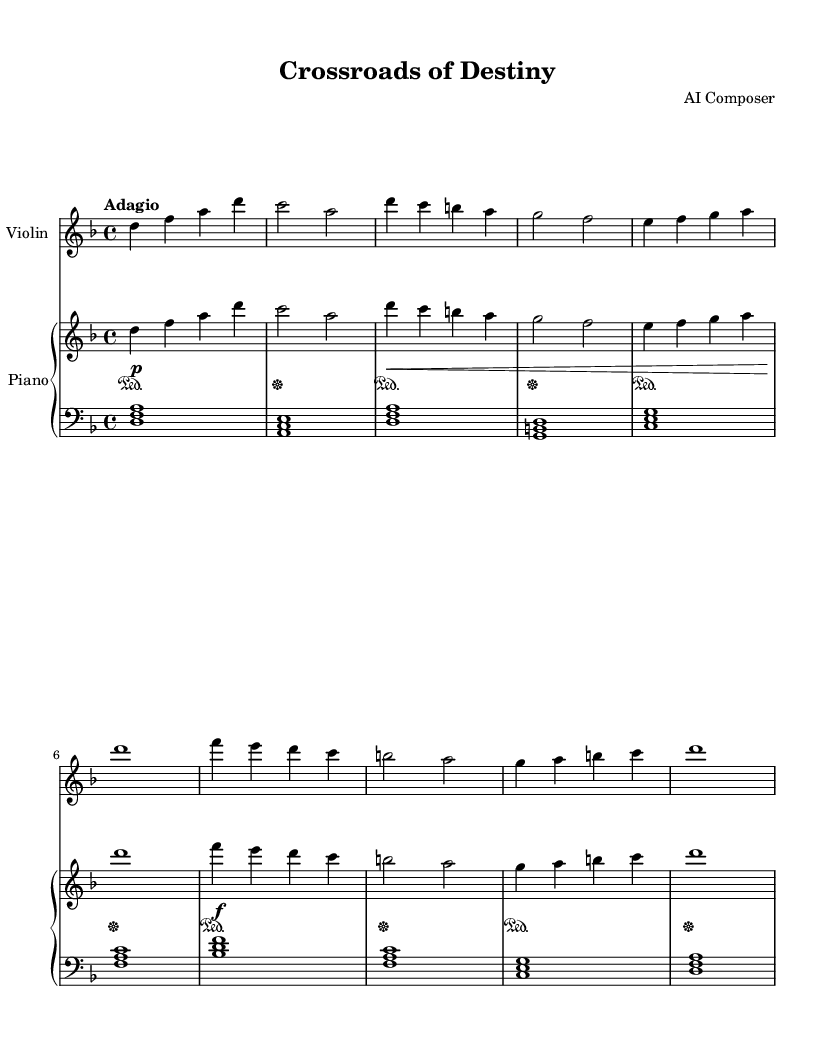What is the key signature of this music? The key signature is indicated at the beginning of the staff. In this case, there are six flats, which corresponds to the key of D minor.
Answer: D minor What is the time signature of this music? The time signature appears at the beginning of the score, shown as a fraction with a four on top and a four on the bottom. This indicates that there are four beats in each measure, and a quarter note gets one beat.
Answer: Four-four What is the tempo marking for this piece? The tempo marking is typically indicated just above the staff and is written as "Adagio." This term indicates a slow and leisurely pace.
Answer: Adagio How many sections are present in the music? By examining the structure of the score, it can be identified that there are two distinct sections, labeled as "Section A" and "Section B," which showcase varied themes or ideas.
Answer: Two What is the highest note in Section A? In Section A, the notes progress from D down to A. The highest note, looking at the given notes, is D.
Answer: D What dynamics are indicated in the music? The dynamics are detailed in the score, which shows various symbols representing how loud or soft the music should be played, including markings like piano (soft), forte (loud), and crescendo.
Answer: Piano, forte, crescendo What instrument plays the melody in this composition? By examining the score layout, it is evident that the violin part carries the primary melody throughout the piece, thus it is the lead instrument.
Answer: Violin 